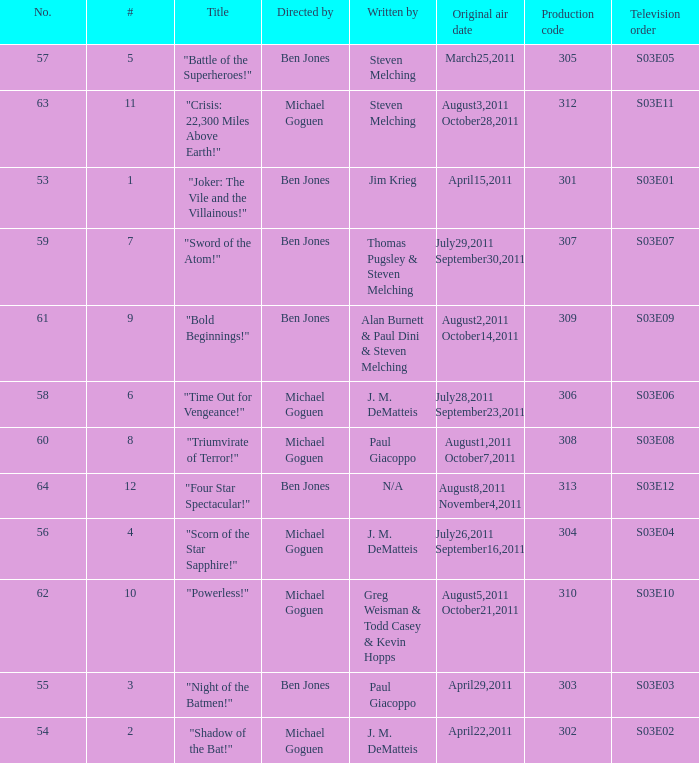What is the original air date of the episode directed by ben jones and written by steven melching?  March25,2011. 